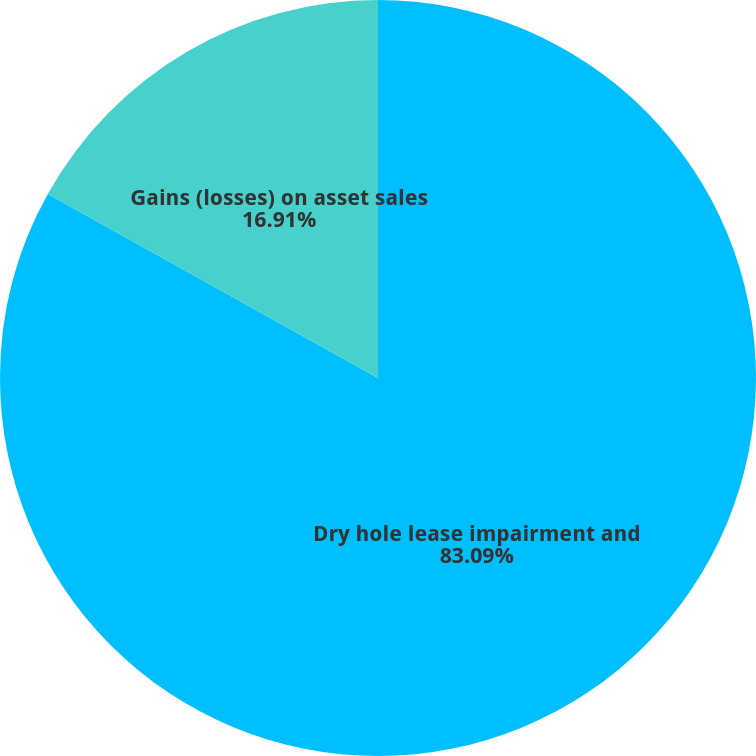<chart> <loc_0><loc_0><loc_500><loc_500><pie_chart><fcel>Dry hole lease impairment and<fcel>Gains (losses) on asset sales<nl><fcel>83.09%<fcel>16.91%<nl></chart> 